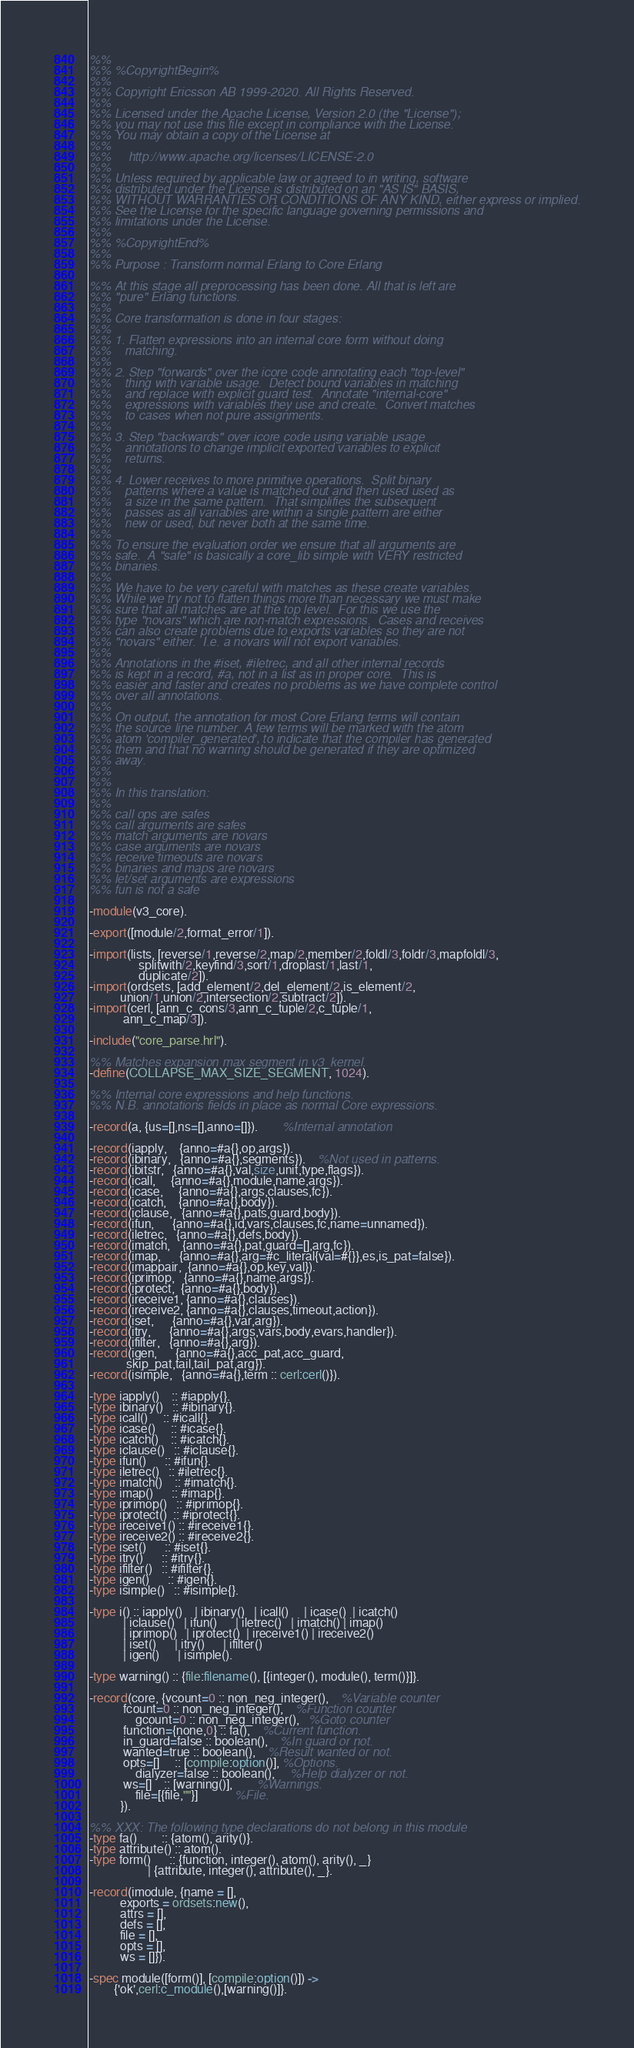<code> <loc_0><loc_0><loc_500><loc_500><_Erlang_>%%
%% %CopyrightBegin%
%%
%% Copyright Ericsson AB 1999-2020. All Rights Reserved.
%%
%% Licensed under the Apache License, Version 2.0 (the "License");
%% you may not use this file except in compliance with the License.
%% You may obtain a copy of the License at
%%
%%     http://www.apache.org/licenses/LICENSE-2.0
%%
%% Unless required by applicable law or agreed to in writing, software
%% distributed under the License is distributed on an "AS IS" BASIS,
%% WITHOUT WARRANTIES OR CONDITIONS OF ANY KIND, either express or implied.
%% See the License for the specific language governing permissions and
%% limitations under the License.
%%
%% %CopyrightEnd%
%%
%% Purpose : Transform normal Erlang to Core Erlang

%% At this stage all preprocessing has been done. All that is left are
%% "pure" Erlang functions.
%%
%% Core transformation is done in four stages:
%%
%% 1. Flatten expressions into an internal core form without doing
%%    matching.
%%
%% 2. Step "forwards" over the icore code annotating each "top-level"
%%    thing with variable usage.  Detect bound variables in matching
%%    and replace with explicit guard test.  Annotate "internal-core"
%%    expressions with variables they use and create.  Convert matches
%%    to cases when not pure assignments.
%%
%% 3. Step "backwards" over icore code using variable usage
%%    annotations to change implicit exported variables to explicit
%%    returns.
%%
%% 4. Lower receives to more primitive operations.  Split binary
%%    patterns where a value is matched out and then used used as
%%    a size in the same pattern.  That simplifies the subsequent
%%    passes as all variables are within a single pattern are either
%%    new or used, but never both at the same time.
%%
%% To ensure the evaluation order we ensure that all arguments are
%% safe.  A "safe" is basically a core_lib simple with VERY restricted
%% binaries.
%%
%% We have to be very careful with matches as these create variables.
%% While we try not to flatten things more than necessary we must make
%% sure that all matches are at the top level.  For this we use the
%% type "novars" which are non-match expressions.  Cases and receives
%% can also create problems due to exports variables so they are not
%% "novars" either.  I.e. a novars will not export variables.
%%
%% Annotations in the #iset, #iletrec, and all other internal records
%% is kept in a record, #a, not in a list as in proper core.  This is
%% easier and faster and creates no problems as we have complete control
%% over all annotations.
%%
%% On output, the annotation for most Core Erlang terms will contain
%% the source line number. A few terms will be marked with the atom
%% atom 'compiler_generated', to indicate that the compiler has generated
%% them and that no warning should be generated if they are optimized
%% away.
%% 
%%
%% In this translation:
%%
%% call ops are safes
%% call arguments are safes
%% match arguments are novars
%% case arguments are novars
%% receive timeouts are novars
%% binaries and maps are novars
%% let/set arguments are expressions
%% fun is not a safe

-module(v3_core).

-export([module/2,format_error/1]).

-import(lists, [reverse/1,reverse/2,map/2,member/2,foldl/3,foldr/3,mapfoldl/3,
                splitwith/2,keyfind/3,sort/1,droplast/1,last/1,
                duplicate/2]).
-import(ordsets, [add_element/2,del_element/2,is_element/2,
		  union/1,union/2,intersection/2,subtract/2]).
-import(cerl, [ann_c_cons/3,ann_c_tuple/2,c_tuple/1,
	       ann_c_map/3]).

-include("core_parse.hrl").

%% Matches expansion max segment in v3_kernel.
-define(COLLAPSE_MAX_SIZE_SEGMENT, 1024).

%% Internal core expressions and help functions.
%% N.B. annotations fields in place as normal Core expressions.

-record(a, {us=[],ns=[],anno=[]}).		%Internal annotation

-record(iapply,    {anno=#a{},op,args}).
-record(ibinary,   {anno=#a{},segments}).	%Not used in patterns.
-record(ibitstr,   {anno=#a{},val,size,unit,type,flags}).
-record(icall,     {anno=#a{},module,name,args}).
-record(icase,     {anno=#a{},args,clauses,fc}).
-record(icatch,    {anno=#a{},body}).
-record(iclause,   {anno=#a{},pats,guard,body}).
-record(ifun,      {anno=#a{},id,vars,clauses,fc,name=unnamed}).
-record(iletrec,   {anno=#a{},defs,body}).
-record(imatch,    {anno=#a{},pat,guard=[],arg,fc}).
-record(imap,      {anno=#a{},arg=#c_literal{val=#{}},es,is_pat=false}).
-record(imappair,  {anno=#a{},op,key,val}).
-record(iprimop,   {anno=#a{},name,args}).
-record(iprotect,  {anno=#a{},body}).
-record(ireceive1, {anno=#a{},clauses}).
-record(ireceive2, {anno=#a{},clauses,timeout,action}).
-record(iset,      {anno=#a{},var,arg}).
-record(itry,      {anno=#a{},args,vars,body,evars,handler}).
-record(ifilter,   {anno=#a{},arg}).
-record(igen,      {anno=#a{},acc_pat,acc_guard,
		    skip_pat,tail,tail_pat,arg}).
-record(isimple,   {anno=#a{},term :: cerl:cerl()}).

-type iapply()    :: #iapply{}.
-type ibinary()   :: #ibinary{}.
-type icall()     :: #icall{}.
-type icase()     :: #icase{}.
-type icatch()    :: #icatch{}.
-type iclause()   :: #iclause{}.
-type ifun()      :: #ifun{}.
-type iletrec()   :: #iletrec{}.
-type imatch()    :: #imatch{}.
-type imap()      :: #imap{}.
-type iprimop()   :: #iprimop{}.
-type iprotect()  :: #iprotect{}.
-type ireceive1() :: #ireceive1{}.
-type ireceive2() :: #ireceive2{}.
-type iset()      :: #iset{}.
-type itry()      :: #itry{}.
-type ifilter()   :: #ifilter{}.
-type igen()      :: #igen{}.
-type isimple()   :: #isimple{}.

-type i() :: iapply()    | ibinary()   | icall()     | icase()  | icatch()
           | iclause()   | ifun()      | iletrec()   | imatch() | imap()
           | iprimop()   | iprotect()  | ireceive1() | ireceive2()
           | iset()      | itry()      | ifilter()
           | igen()      | isimple().

-type warning() :: {file:filename(), [{integer(), module(), term()}]}.

-record(core, {vcount=0 :: non_neg_integer(),	%Variable counter
	       fcount=0 :: non_neg_integer(),	%Function counter
               gcount=0 :: non_neg_integer(),   %Goto counter
	       function={none,0} :: fa(),	%Current function.
	       in_guard=false :: boolean(),	%In guard or not.
	       wanted=true :: boolean(),	%Result wanted or not.
	       opts=[]     :: [compile:option()], %Options.
               dialyzer=false :: boolean(),     %Help dialyzer or not.
	       ws=[]    :: [warning()],		%Warnings.
               file=[{file,""}]			%File.
	      }).

%% XXX: The following type declarations do not belong in this module
-type fa()        :: {atom(), arity()}.
-type attribute() :: atom().
-type form()      :: {function, integer(), atom(), arity(), _}
                   | {attribute, integer(), attribute(), _}.

-record(imodule, {name = [],
		  exports = ordsets:new(),
		  attrs = [],
		  defs = [],
		  file = [],
		  opts = [],
		  ws = []}).

-spec module([form()], [compile:option()]) ->
        {'ok',cerl:c_module(),[warning()]}.
</code> 